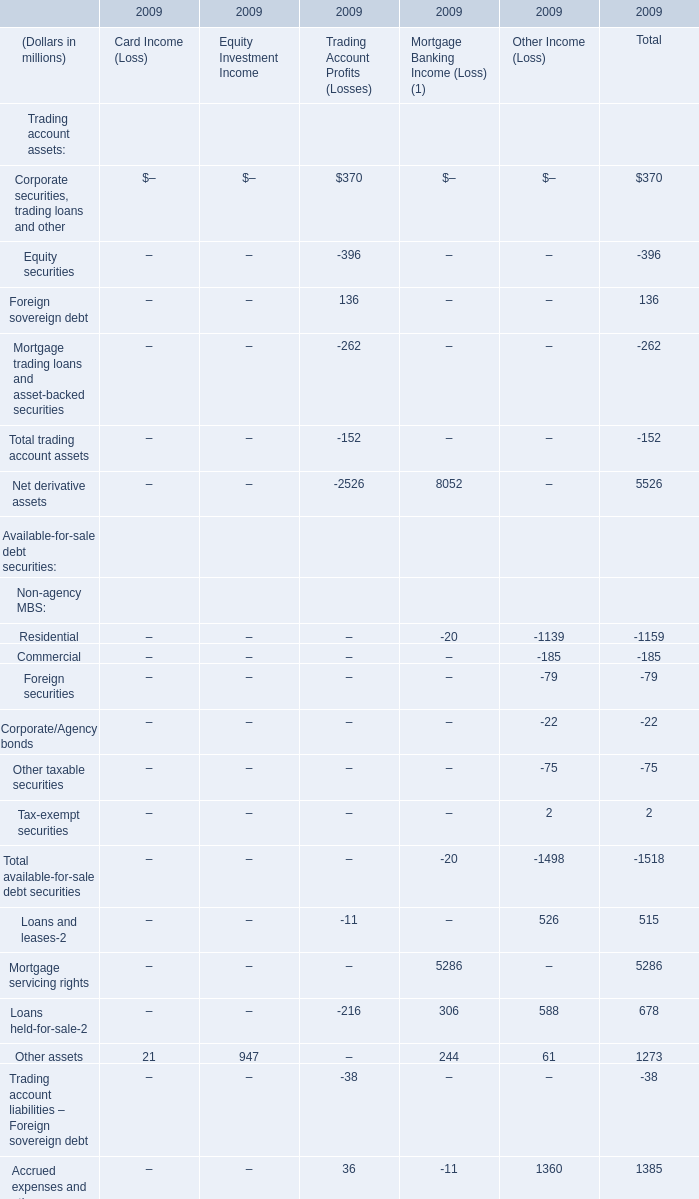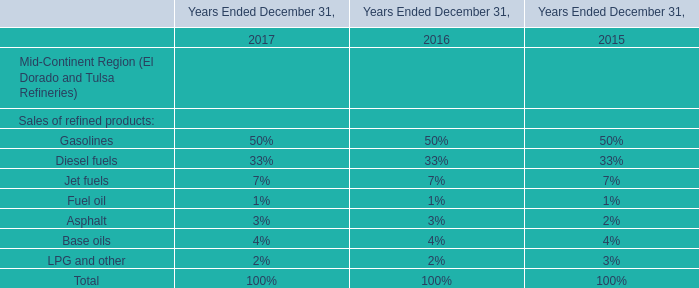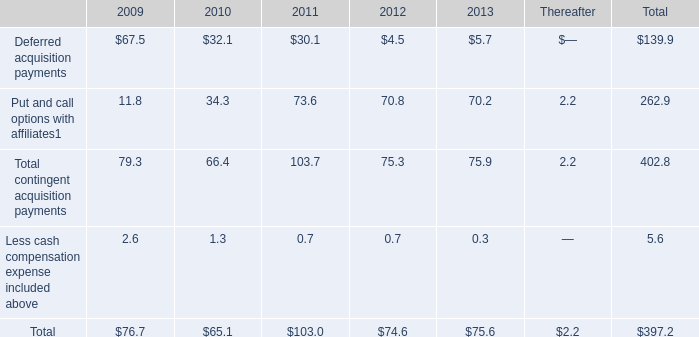What's the average of Total in 2009 and 2008? (in million) 
Computations: ((10645 - 12136) / 2)
Answer: -745.5. 